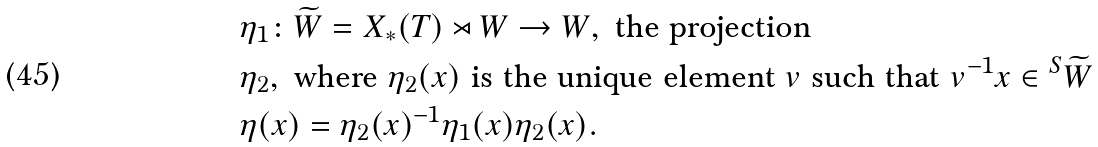<formula> <loc_0><loc_0><loc_500><loc_500>& \eta _ { 1 } \colon \widetilde { W } = X _ { * } ( T ) \rtimes W \rightarrow W , \text { the projection} \\ & \eta _ { 2 } , \text { where $\eta_{2}(x)$ is the unique element $v$ such that $v^{-1}x\in {^{S}}\widetilde{W}$} \\ & \eta ( x ) = \eta _ { 2 } ( x ) ^ { - 1 } \eta _ { 1 } ( x ) \eta _ { 2 } ( x ) .</formula> 